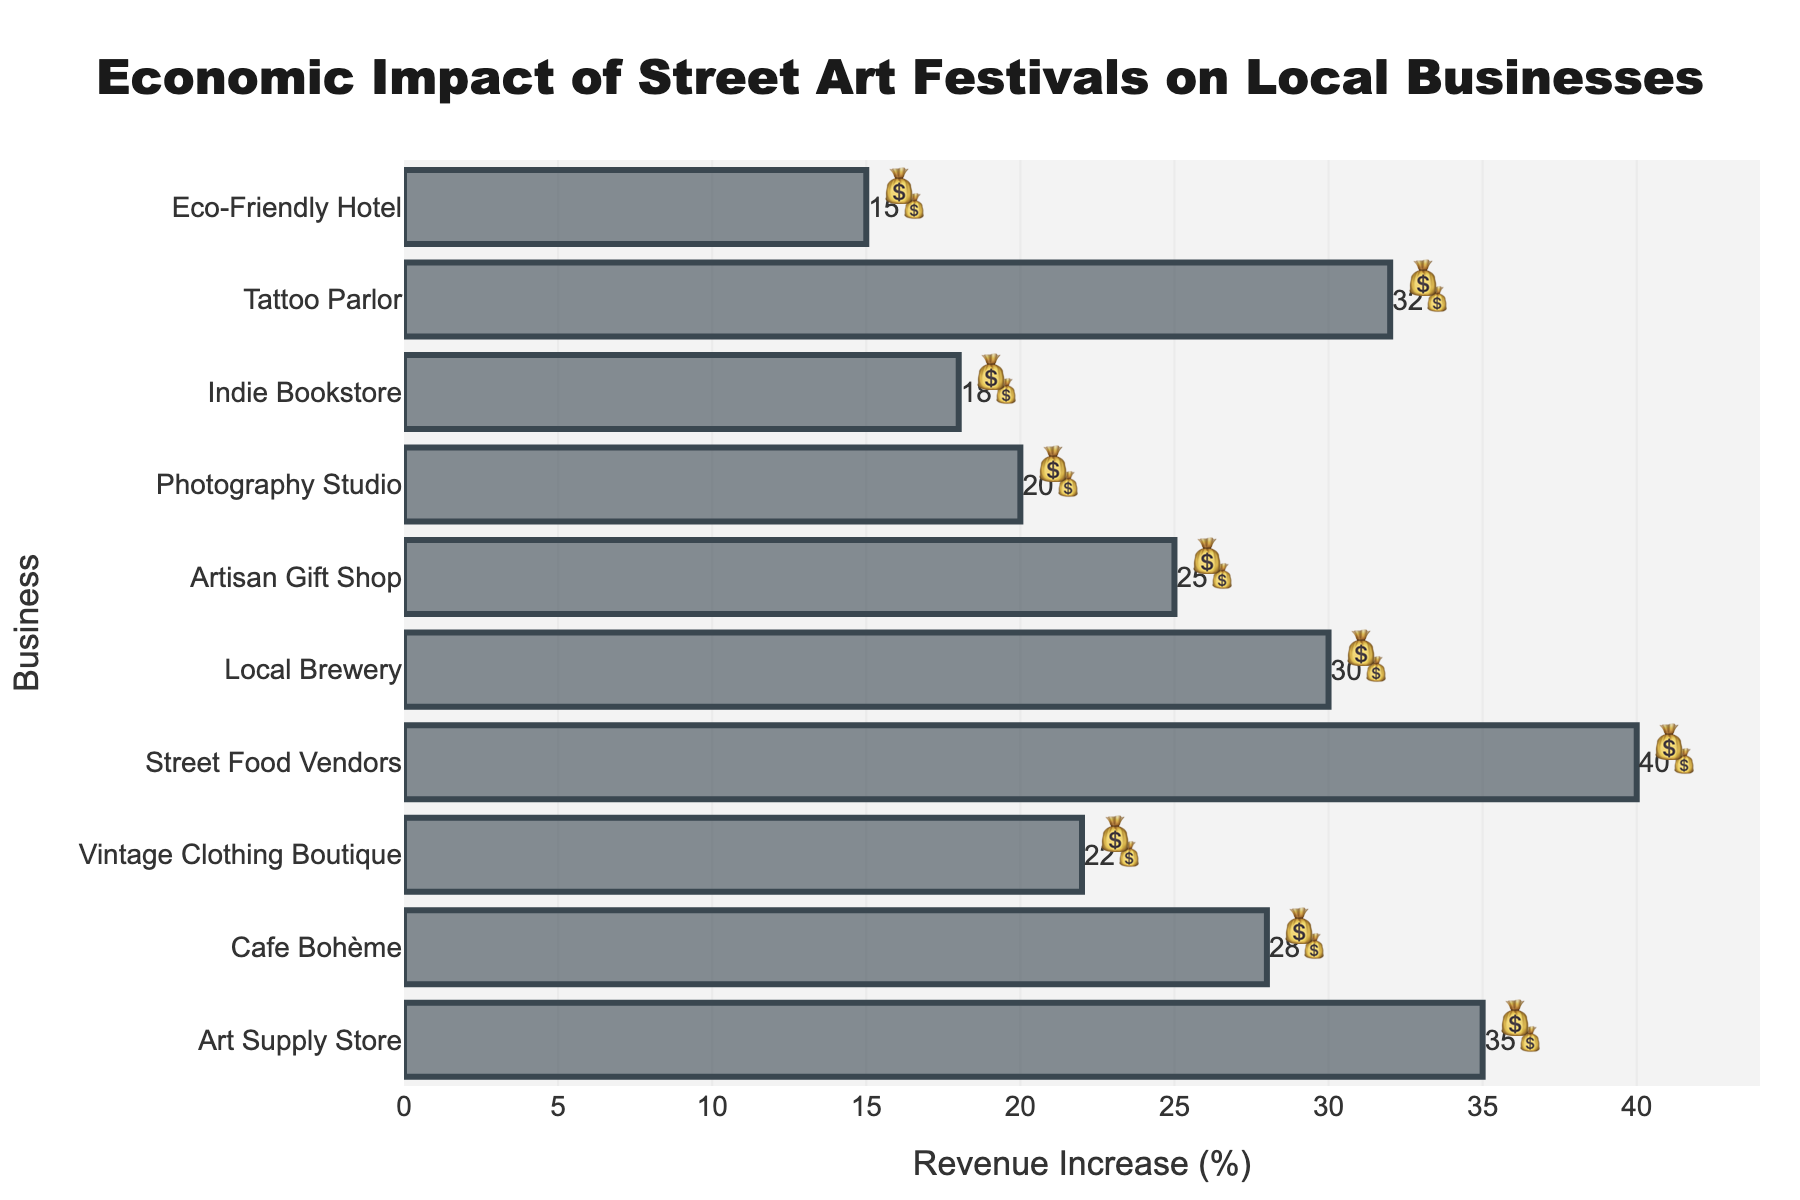What's the title of the chart? The title is located at the top of the chart and reads "Economic Impact of Street Art Festivals on Local Businesses".
Answer: Economic Impact of Street Art Festivals on Local Businesses What is the revenue increase percentage for the Street Food Vendors? The Street Food Vendors bar has a text label indicating a 40% revenue increase, along with corresponding emoji.
Answer: 40% Which business has the lowest revenue increase and what is the percentage? The chart shows bars for each business, and the shortest bar represents the Eco-Friendly Hotel with a 15% revenue increase.
Answer: Eco-Friendly Hotel, 15% How many businesses experienced a revenue increase of more than 30%? We count the bars with a text label showing more than 30%. These businesses are the Art Supply Store (35%), Street Food Vendors (40%), Tattoo Parlor (32%), and Local Brewery (30%).
Answer: Four businesses What's the average revenue increase across all businesses? Add each of the percentages (35 + 28 + 22 + 40 + 30 + 25 + 20 + 18 + 32 + 15) to get a total of 265. Then divide by the number of businesses (10). 265 / 10 = 26.5.
Answer: 26.5% Which two businesses have the closest revenue increase percentages and what are they? Looking at the chart, the Cafe Bohème (28%) and Local Brewery (30%) have the closest values with only a 2% difference.
Answer: Cafe Bohème 28% and Local Brewery 30% What's the total revenue increase percentage if you sum up the top three businesses with the highest increases? The top three are Street Food Vendors (40%), Art Supply Store (35%), and Tattoo Parlor (32%). Summing these gives 40 + 35 + 32 = 107.
Answer: 107% Which business is positioned exactly in the middle when sorted by revenue increase? When listed in order: Eco-Friendly Hotel (15%), Indie Bookstore (18%), Photography Studio (20%), Vintage Clothing Boutique (22%), Artisan Gift Shop (25%), Cafe Bohème (28%), Local Brewery (30%), Tattoo Parlor (32%), Art Supply Store (35%), Street Food Vendors (40%), the middle business is the Artisan Gift Shop with a 25% increase.
Answer: Artisan Gift Shop, 25% What's the difference in revenue increase between the Vintage Clothing Boutique and Indie Bookstore? The displayed revenues are 22% for Vintage Clothing Boutique and 18% for Indie Bookstore. The difference is 22 - 18 = 4.
Answer: 4% What is the combined revenue increase percentage for the Photography Studio, Indie Bookstore, and Tattoo Parlor? Adding these percentages: 20% (Photography Studio) + 18% (Indie Bookstore) + 32% (Tattoo Parlor) gives a total of 70.
Answer: 70% Between the Cafe Bohème and the Local Brewery, which business has a higher revenue increase and by how much? The revenue increase for Cafe Bohème is 28% and for Local Brewery is 30%. The difference is 30 - 28 = 2.
Answer: Local Brewery by 2% 